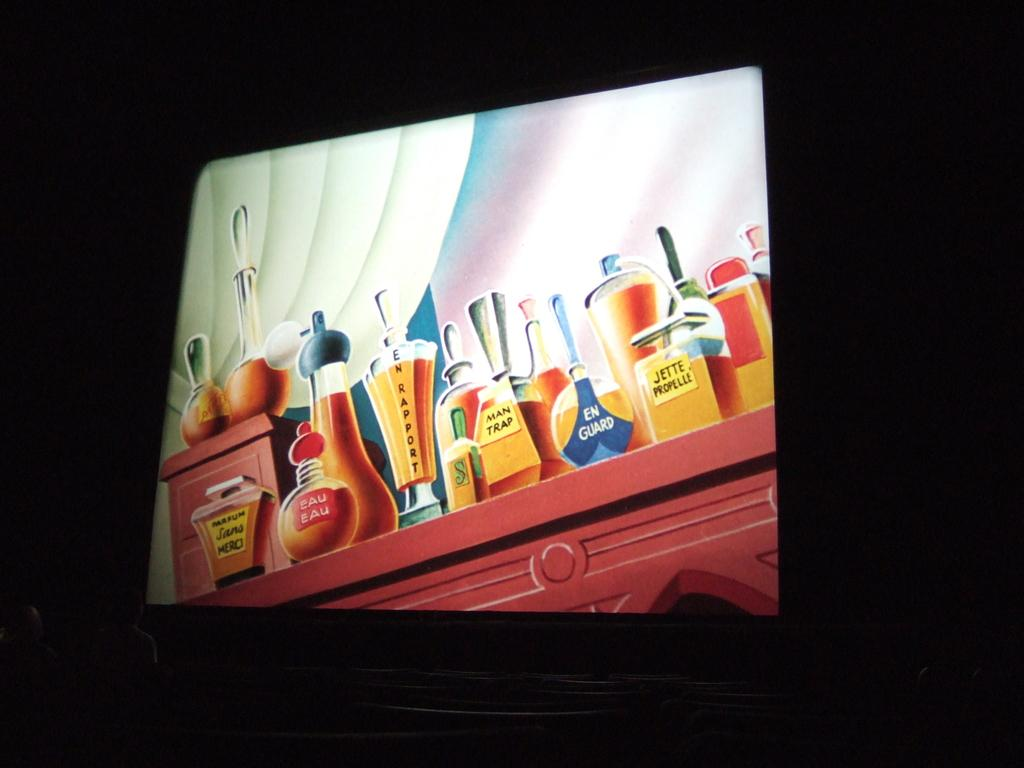<image>
Write a terse but informative summary of the picture. A painting of different perfumes, including one called "man scent". 